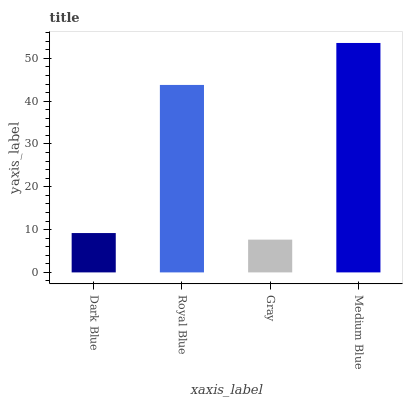Is Gray the minimum?
Answer yes or no. Yes. Is Medium Blue the maximum?
Answer yes or no. Yes. Is Royal Blue the minimum?
Answer yes or no. No. Is Royal Blue the maximum?
Answer yes or no. No. Is Royal Blue greater than Dark Blue?
Answer yes or no. Yes. Is Dark Blue less than Royal Blue?
Answer yes or no. Yes. Is Dark Blue greater than Royal Blue?
Answer yes or no. No. Is Royal Blue less than Dark Blue?
Answer yes or no. No. Is Royal Blue the high median?
Answer yes or no. Yes. Is Dark Blue the low median?
Answer yes or no. Yes. Is Dark Blue the high median?
Answer yes or no. No. Is Gray the low median?
Answer yes or no. No. 